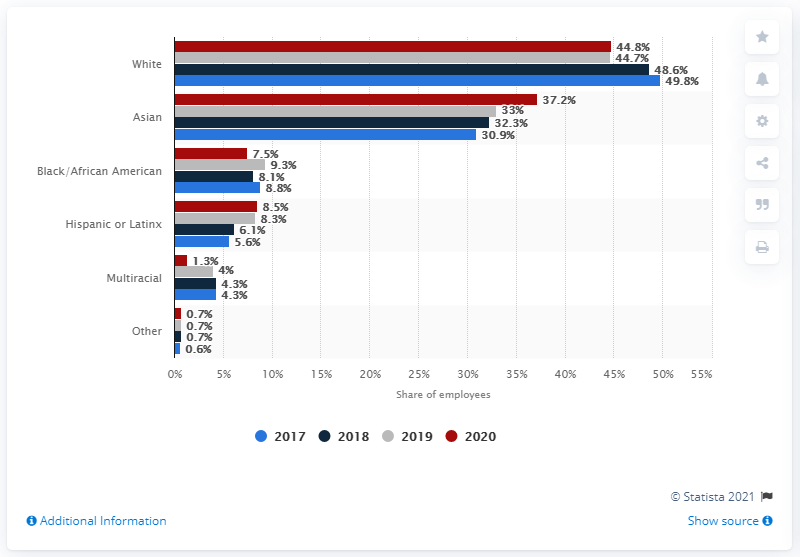List a handful of essential elements in this visual. According to data from 2020, a significant portion of U.S. Uber employees, approximately 37.2 percent, identified as Asian. 